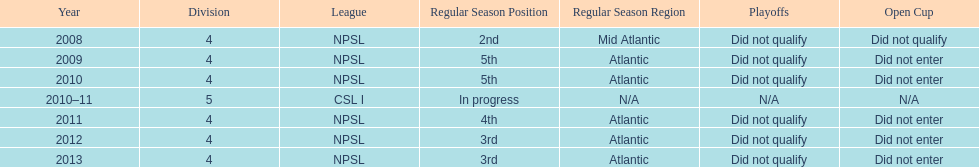Using the data, what should be the next year they will play? 2014. 